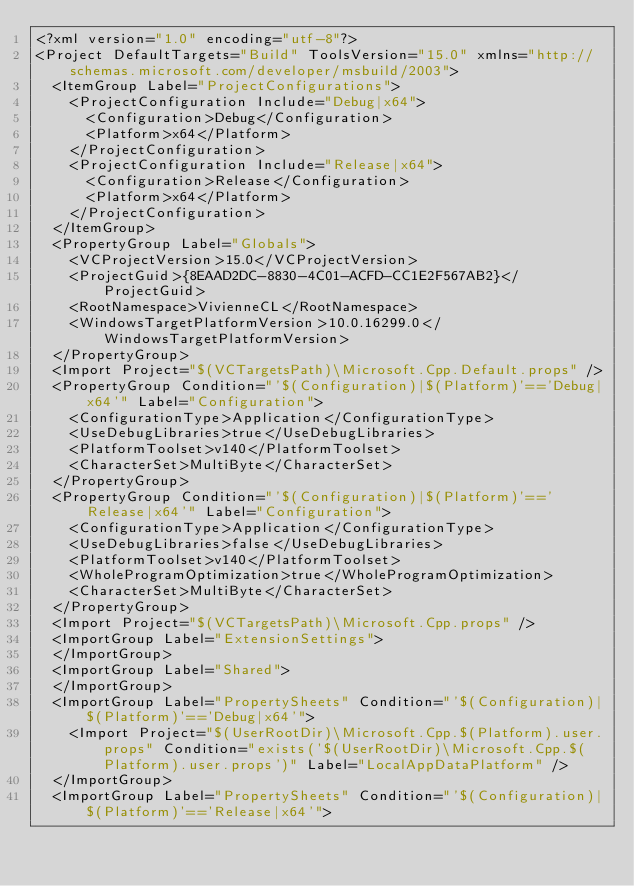<code> <loc_0><loc_0><loc_500><loc_500><_XML_><?xml version="1.0" encoding="utf-8"?>
<Project DefaultTargets="Build" ToolsVersion="15.0" xmlns="http://schemas.microsoft.com/developer/msbuild/2003">
  <ItemGroup Label="ProjectConfigurations">
    <ProjectConfiguration Include="Debug|x64">
      <Configuration>Debug</Configuration>
      <Platform>x64</Platform>
    </ProjectConfiguration>
    <ProjectConfiguration Include="Release|x64">
      <Configuration>Release</Configuration>
      <Platform>x64</Platform>
    </ProjectConfiguration>
  </ItemGroup>
  <PropertyGroup Label="Globals">
    <VCProjectVersion>15.0</VCProjectVersion>
    <ProjectGuid>{8EAAD2DC-8830-4C01-ACFD-CC1E2F567AB2}</ProjectGuid>
    <RootNamespace>VivienneCL</RootNamespace>
    <WindowsTargetPlatformVersion>10.0.16299.0</WindowsTargetPlatformVersion>
  </PropertyGroup>
  <Import Project="$(VCTargetsPath)\Microsoft.Cpp.Default.props" />
  <PropertyGroup Condition="'$(Configuration)|$(Platform)'=='Debug|x64'" Label="Configuration">
    <ConfigurationType>Application</ConfigurationType>
    <UseDebugLibraries>true</UseDebugLibraries>
    <PlatformToolset>v140</PlatformToolset>
    <CharacterSet>MultiByte</CharacterSet>
  </PropertyGroup>
  <PropertyGroup Condition="'$(Configuration)|$(Platform)'=='Release|x64'" Label="Configuration">
    <ConfigurationType>Application</ConfigurationType>
    <UseDebugLibraries>false</UseDebugLibraries>
    <PlatformToolset>v140</PlatformToolset>
    <WholeProgramOptimization>true</WholeProgramOptimization>
    <CharacterSet>MultiByte</CharacterSet>
  </PropertyGroup>
  <Import Project="$(VCTargetsPath)\Microsoft.Cpp.props" />
  <ImportGroup Label="ExtensionSettings">
  </ImportGroup>
  <ImportGroup Label="Shared">
  </ImportGroup>
  <ImportGroup Label="PropertySheets" Condition="'$(Configuration)|$(Platform)'=='Debug|x64'">
    <Import Project="$(UserRootDir)\Microsoft.Cpp.$(Platform).user.props" Condition="exists('$(UserRootDir)\Microsoft.Cpp.$(Platform).user.props')" Label="LocalAppDataPlatform" />
  </ImportGroup>
  <ImportGroup Label="PropertySheets" Condition="'$(Configuration)|$(Platform)'=='Release|x64'"></code> 